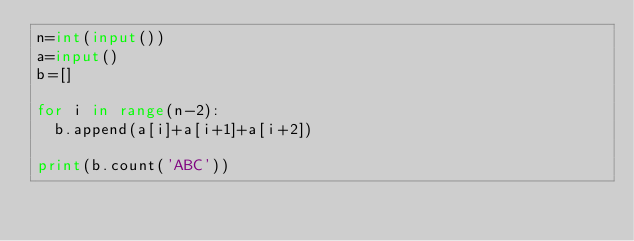Convert code to text. <code><loc_0><loc_0><loc_500><loc_500><_Python_>n=int(input())
a=input()
b=[]

for i in range(n-2):
  b.append(a[i]+a[i+1]+a[i+2])
  
print(b.count('ABC'))</code> 